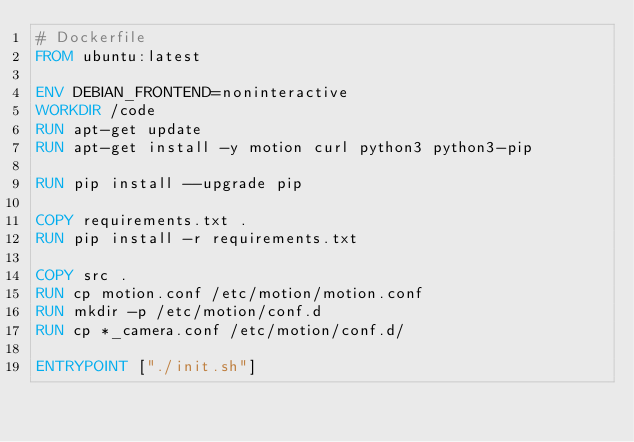Convert code to text. <code><loc_0><loc_0><loc_500><loc_500><_Dockerfile_># Dockerfile
FROM ubuntu:latest

ENV DEBIAN_FRONTEND=noninteractive
WORKDIR /code
RUN apt-get update
RUN apt-get install -y motion curl python3 python3-pip

RUN pip install --upgrade pip

COPY requirements.txt .
RUN pip install -r requirements.txt

COPY src .
RUN cp motion.conf /etc/motion/motion.conf
RUN mkdir -p /etc/motion/conf.d
RUN cp *_camera.conf /etc/motion/conf.d/

ENTRYPOINT ["./init.sh"]
</code> 